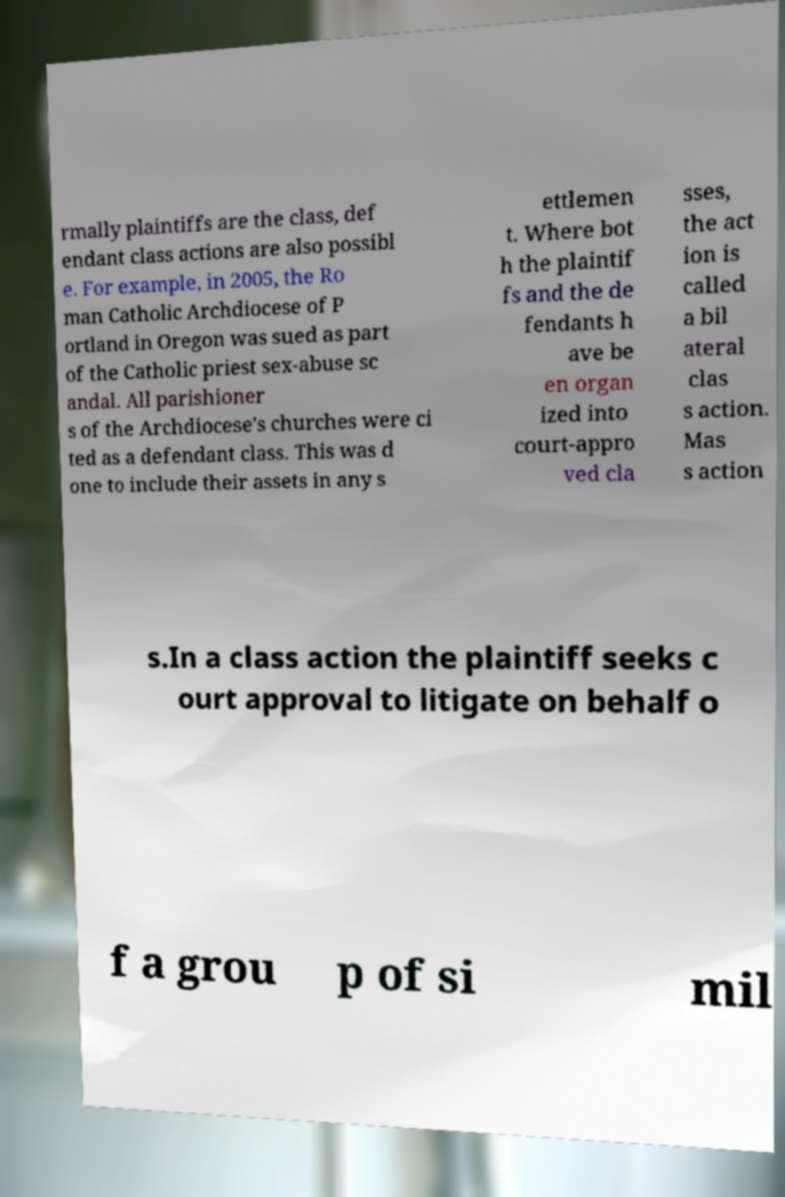Please identify and transcribe the text found in this image. rmally plaintiffs are the class, def endant class actions are also possibl e. For example, in 2005, the Ro man Catholic Archdiocese of P ortland in Oregon was sued as part of the Catholic priest sex-abuse sc andal. All parishioner s of the Archdiocese's churches were ci ted as a defendant class. This was d one to include their assets in any s ettlemen t. Where bot h the plaintif fs and the de fendants h ave be en organ ized into court-appro ved cla sses, the act ion is called a bil ateral clas s action. Mas s action s.In a class action the plaintiff seeks c ourt approval to litigate on behalf o f a grou p of si mil 